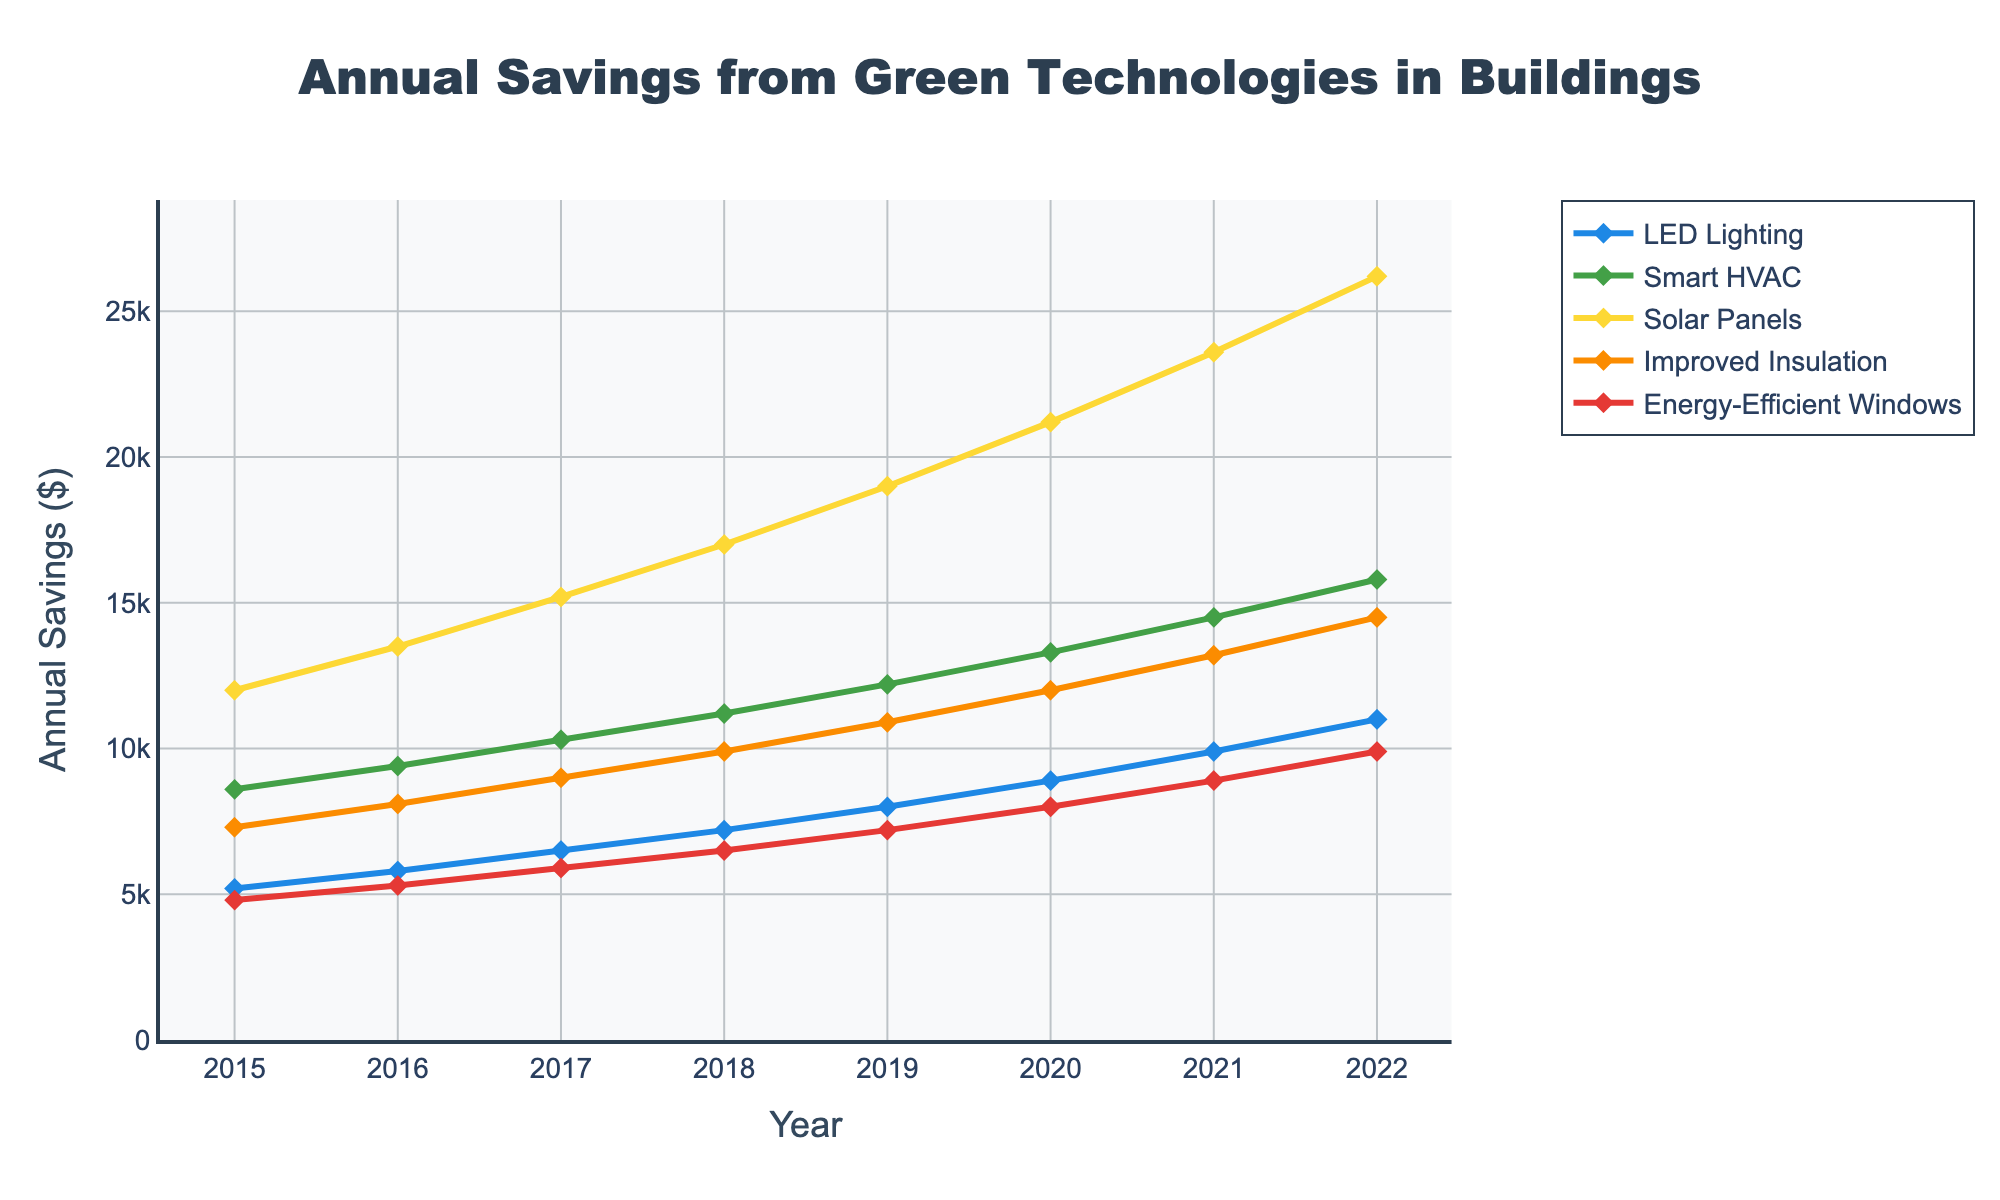What is the savings trend observed for LED Lighting from 2015 to 2022? The annual savings for LED Lighting is increasing consistently each year from 5200 in 2015 to 11000 in 2022. This shows a positive trend of increasing savings over time.
Answer: Increasing trend Which green technology showed the highest annual savings in 2022? By looking at the figure, Solar Panels have the highest annual savings in 2022, with a value of 26200 compared to other technologies.
Answer: Solar Panels How much more did Improved Insulation save in 2020 compared to 2015? In 2020, Improved Insulation saved 12000, while in 2015, it saved 7300. To find the difference: 12000 - 7300 = 4700.
Answer: 4700 Which technology had the smallest increase in annual savings from 2015 to 2022? By comparing the starting and ending savings for each technology: LED Lighting increased from 5200 to 11000 (+5800), Smart HVAC from 8600 to 15800 (+7200), Solar Panels from 12000 to 26200 (+14200), Improved Insulation from 7300 to 14500 (+7200), and Energy-Efficient Windows from 4800 to 9900 (+5100). The technology with the smallest increase is Energy-Efficient Windows.
Answer: Energy-Efficient Windows What is the average annual savings for Smart HVAC over the years shown? To calculate the average, sum the annual savings for each year (8600 + 9400 + 10300 + 11200 + 12200 + 13300 + 14500 + 15800) and divide by the number of years (8). Sum = 95300; average = 95300 / 8 = 11912.5.
Answer: 11912.5 How does the savings for Energy-Efficient Windows in 2019 compare to that of Smart HVAC in 2017? In 2019, Energy-Efficient Windows saved 7200, whereas in 2017, Smart HVAC saved 10300. Thus, Smart HVAC in 2017 saved significantly more (10300 - 7200 = 3100).
Answer: Smart HVAC saves 3100 more Which year shows the greatest increase in savings for Solar Panels compared to the previous year? By calculating the yearly increase, we get: 2016-2015: 1500, 2017-2016: 1700, 2018-2017: 1800, 2019-2018: 2000, 2020-2019: 2200, 2021-2020: 2400, 2022-2021: 2600. The greatest increase is from 2021 to 2022 with an increase of 2600.
Answer: 2021-2022 What is the combined savings in 2020 for LED Lighting and Improved Insulation? By looking at the figure, the savings for LED Lighting in 2020 is 8900 and for Improved Insulation is 12000. The combined savings are 8900 + 12000 = 20900.
Answer: 20900 